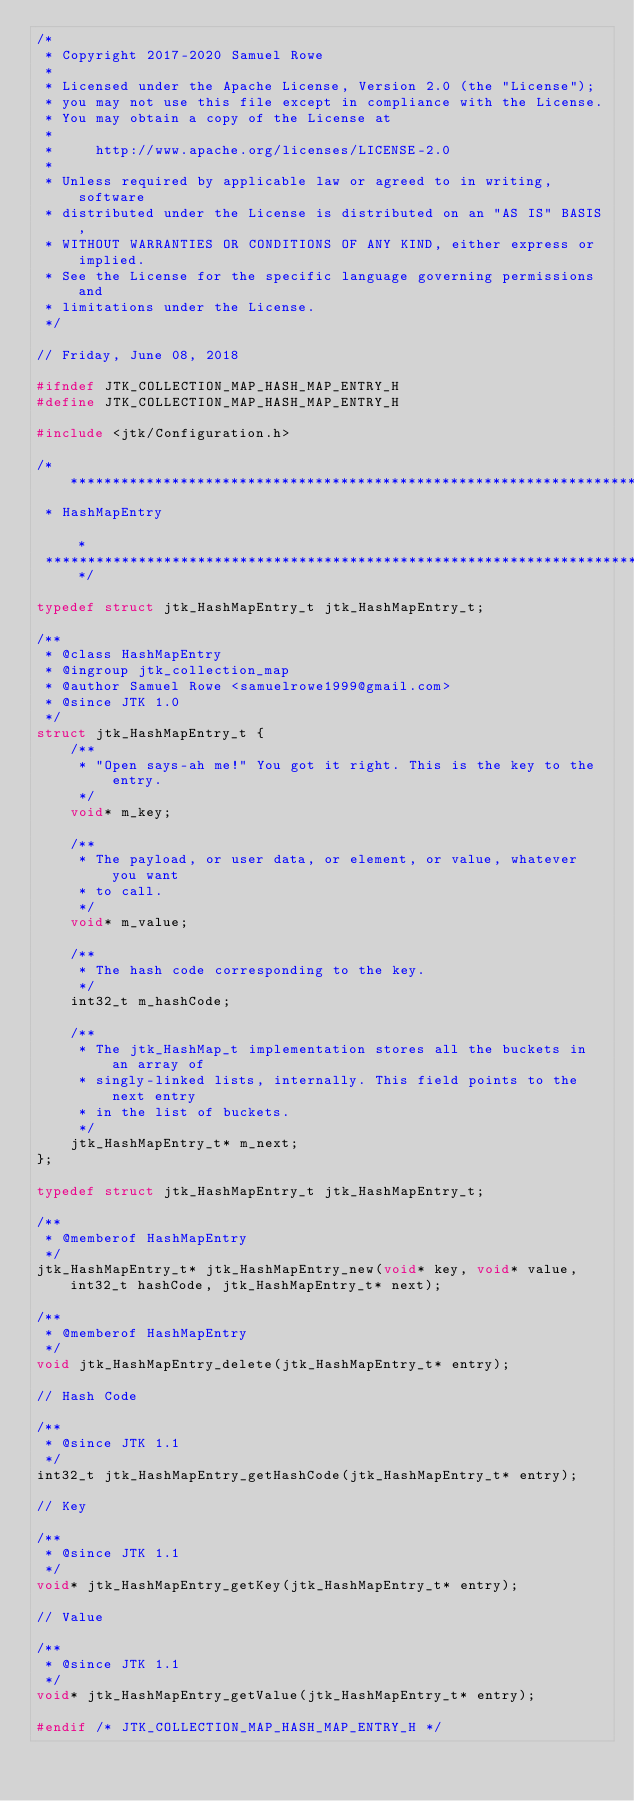<code> <loc_0><loc_0><loc_500><loc_500><_C_>/*
 * Copyright 2017-2020 Samuel Rowe
 *
 * Licensed under the Apache License, Version 2.0 (the "License");
 * you may not use this file except in compliance with the License.
 * You may obtain a copy of the License at
 *
 *     http://www.apache.org/licenses/LICENSE-2.0
 *
 * Unless required by applicable law or agreed to in writing, software
 * distributed under the License is distributed on an "AS IS" BASIS,
 * WITHOUT WARRANTIES OR CONDITIONS OF ANY KIND, either express or implied.
 * See the License for the specific language governing permissions and
 * limitations under the License.
 */

// Friday, June 08, 2018

#ifndef JTK_COLLECTION_MAP_HASH_MAP_ENTRY_H
#define JTK_COLLECTION_MAP_HASH_MAP_ENTRY_H

#include <jtk/Configuration.h>

/*******************************************************************************
 * HashMapEntry                                                                *
 *******************************************************************************/

typedef struct jtk_HashMapEntry_t jtk_HashMapEntry_t;

/**
 * @class HashMapEntry
 * @ingroup jtk_collection_map
 * @author Samuel Rowe <samuelrowe1999@gmail.com>
 * @since JTK 1.0
 */
struct jtk_HashMapEntry_t {
    /**
     * "Open says-ah me!" You got it right. This is the key to the entry.
     */
    void* m_key;

    /**
     * The payload, or user data, or element, or value, whatever you want
     * to call.
     */
    void* m_value;

    /**
     * The hash code corresponding to the key.
     */
    int32_t m_hashCode;

    /**
     * The jtk_HashMap_t implementation stores all the buckets in an array of
     * singly-linked lists, internally. This field points to the next entry
     * in the list of buckets.
     */
    jtk_HashMapEntry_t* m_next;
};

typedef struct jtk_HashMapEntry_t jtk_HashMapEntry_t;

/**
 * @memberof HashMapEntry
 */
jtk_HashMapEntry_t* jtk_HashMapEntry_new(void* key, void* value, int32_t hashCode, jtk_HashMapEntry_t* next);

/**
 * @memberof HashMapEntry
 */
void jtk_HashMapEntry_delete(jtk_HashMapEntry_t* entry);

// Hash Code

/**
 * @since JTK 1.1
 */
int32_t jtk_HashMapEntry_getHashCode(jtk_HashMapEntry_t* entry);

// Key

/**
 * @since JTK 1.1
 */
void* jtk_HashMapEntry_getKey(jtk_HashMapEntry_t* entry);

// Value

/**
 * @since JTK 1.1
 */
void* jtk_HashMapEntry_getValue(jtk_HashMapEntry_t* entry);

#endif /* JTK_COLLECTION_MAP_HASH_MAP_ENTRY_H */</code> 